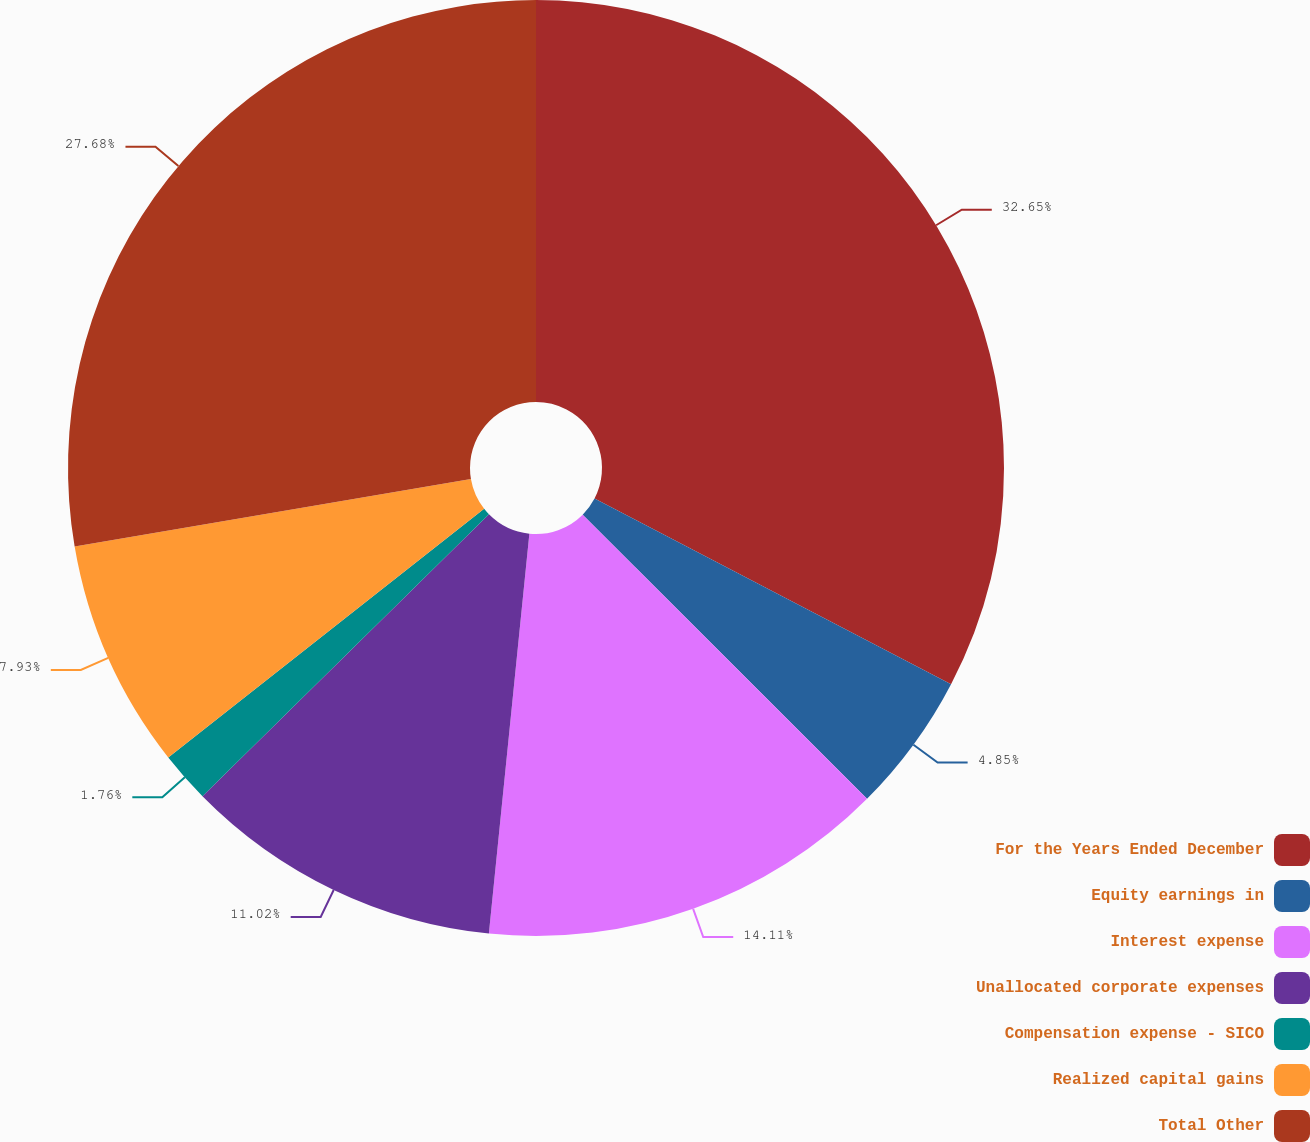Convert chart. <chart><loc_0><loc_0><loc_500><loc_500><pie_chart><fcel>For the Years Ended December<fcel>Equity earnings in<fcel>Interest expense<fcel>Unallocated corporate expenses<fcel>Compensation expense - SICO<fcel>Realized capital gains<fcel>Total Other<nl><fcel>32.64%<fcel>4.85%<fcel>14.11%<fcel>11.02%<fcel>1.76%<fcel>7.93%<fcel>27.68%<nl></chart> 